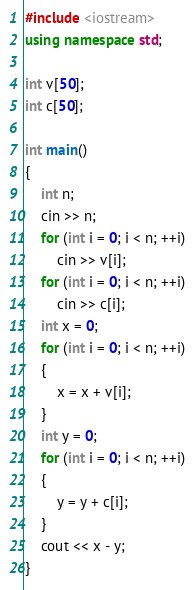Convert code to text. <code><loc_0><loc_0><loc_500><loc_500><_C++_>#include <iostream>
using namespace std;

int v[50];
int c[50];

int main()
{
	int n;
	cin >> n;
	for (int i = 0; i < n; ++i)
		cin >> v[i];
	for (int i = 0; i < n; ++i)
		cin >> c[i];
	int x = 0;
	for (int i = 0; i < n; ++i)
	{
		x = x + v[i];
	}
	int y = 0;
	for (int i = 0; i < n; ++i)
	{
		y = y + c[i];
	}
	cout << x - y;
}</code> 